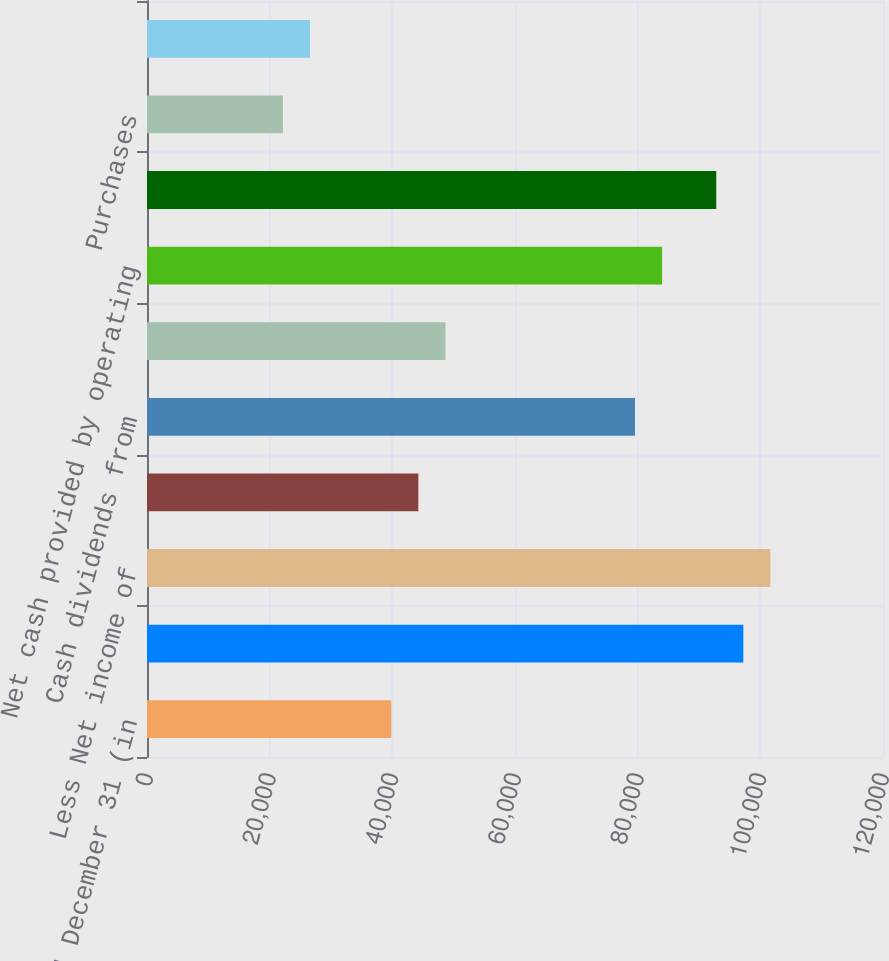Convert chart to OTSL. <chart><loc_0><loc_0><loc_500><loc_500><bar_chart><fcel>Year ended December 31 (in<fcel>Net income<fcel>Less Net income of<fcel>Parent company net loss<fcel>Cash dividends from<fcel>Other net<fcel>Net cash provided by operating<fcel>Deposits with banking<fcel>Purchases<fcel>Proceeds from sales and<nl><fcel>39824.4<fcel>97227.2<fcel>101643<fcel>44240<fcel>79564.8<fcel>48655.6<fcel>83980.4<fcel>92811.6<fcel>22162<fcel>26577.6<nl></chart> 